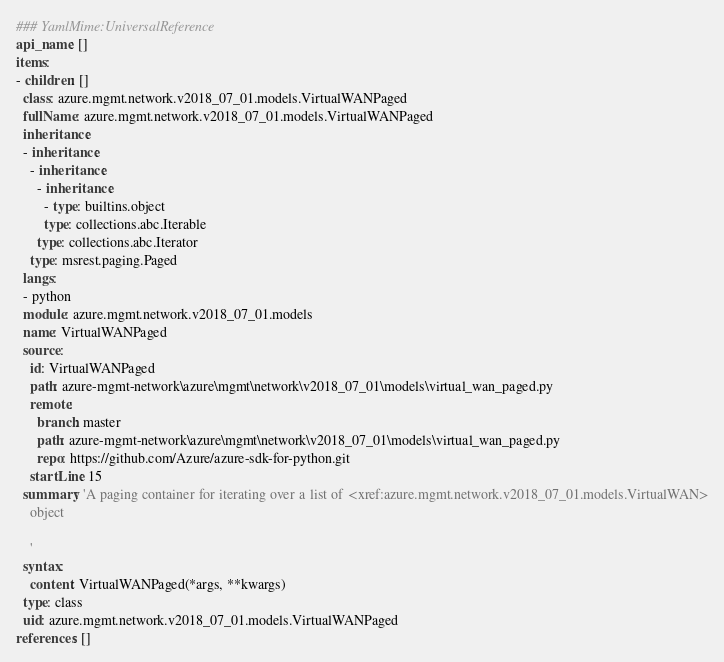Convert code to text. <code><loc_0><loc_0><loc_500><loc_500><_YAML_>### YamlMime:UniversalReference
api_name: []
items:
- children: []
  class: azure.mgmt.network.v2018_07_01.models.VirtualWANPaged
  fullName: azure.mgmt.network.v2018_07_01.models.VirtualWANPaged
  inheritance:
  - inheritance:
    - inheritance:
      - inheritance:
        - type: builtins.object
        type: collections.abc.Iterable
      type: collections.abc.Iterator
    type: msrest.paging.Paged
  langs:
  - python
  module: azure.mgmt.network.v2018_07_01.models
  name: VirtualWANPaged
  source:
    id: VirtualWANPaged
    path: azure-mgmt-network\azure\mgmt\network\v2018_07_01\models\virtual_wan_paged.py
    remote:
      branch: master
      path: azure-mgmt-network\azure\mgmt\network\v2018_07_01\models\virtual_wan_paged.py
      repo: https://github.com/Azure/azure-sdk-for-python.git
    startLine: 15
  summary: 'A paging container for iterating over a list of <xref:azure.mgmt.network.v2018_07_01.models.VirtualWAN>
    object

    '
  syntax:
    content: VirtualWANPaged(*args, **kwargs)
  type: class
  uid: azure.mgmt.network.v2018_07_01.models.VirtualWANPaged
references: []
</code> 